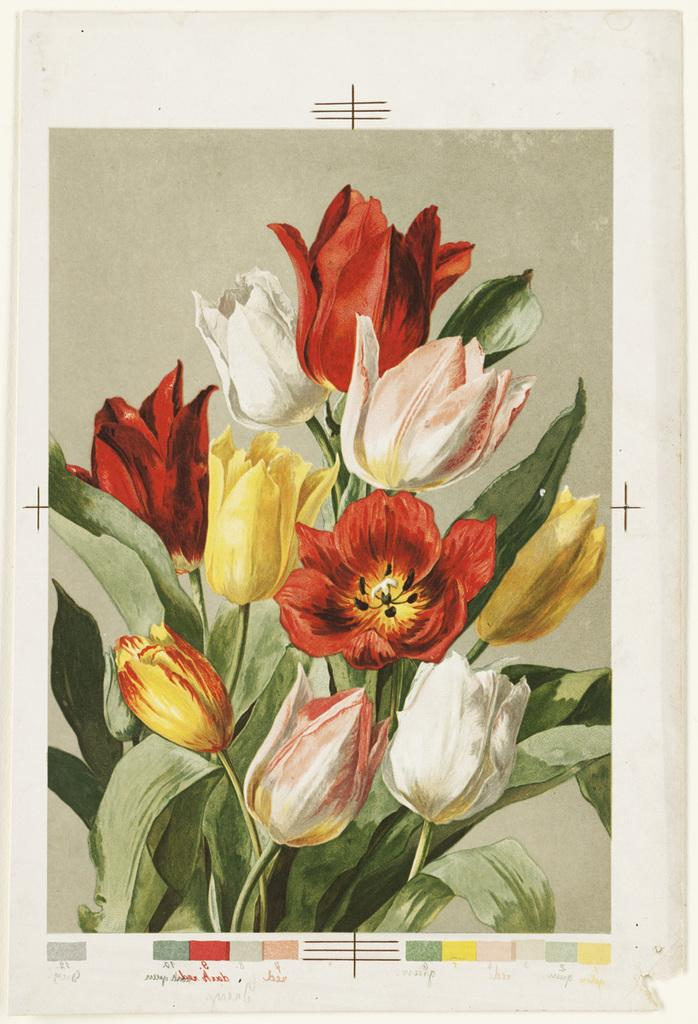What is depicted on the poster in the image? There is a poster of flowers in the image. Is there any text associated with the poster? Yes, there is text at the bottom of the image. Can you see any birds interacting with the friction caused by the poster in the image? There are no birds or friction present in the image; it features a poster of flowers with text at the bottom. How many times does the person in the image kick the poster? There is no person present in the image, and therefore no kicking can be observed. 